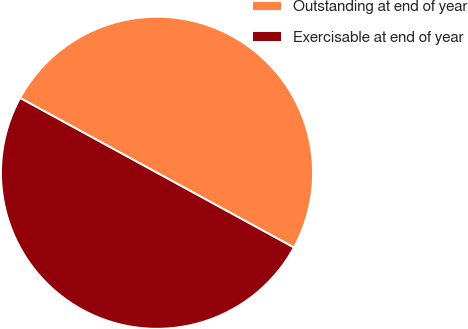Convert chart to OTSL. <chart><loc_0><loc_0><loc_500><loc_500><pie_chart><fcel>Outstanding at end of year<fcel>Exercisable at end of year<nl><fcel>50.0%<fcel>50.0%<nl></chart> 